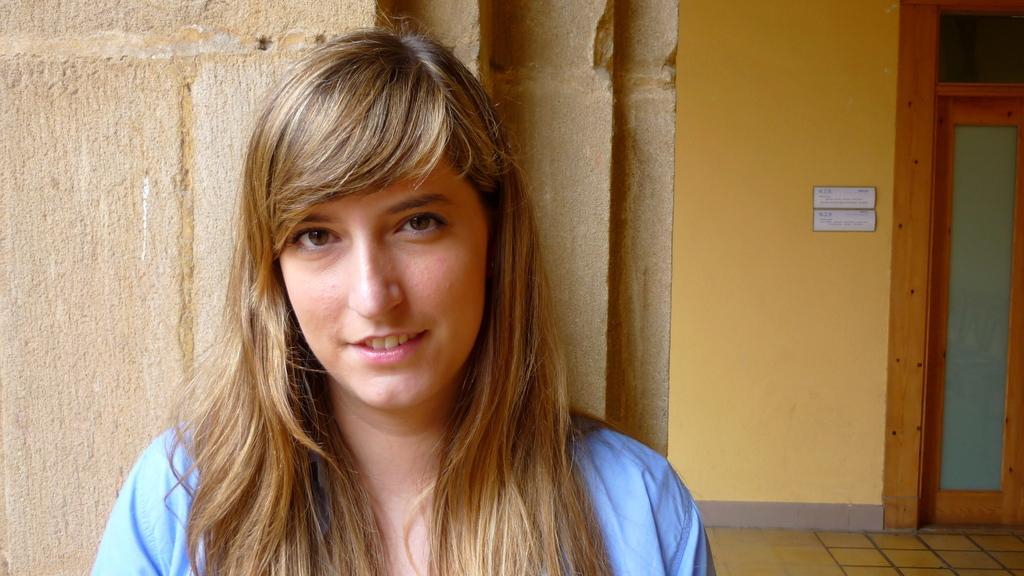In one or two sentences, can you explain what this image depicts? In this image I can see the person wearing the blue color dress. In the background I can see the boards to the yellow color wall and there is a door to the right. 